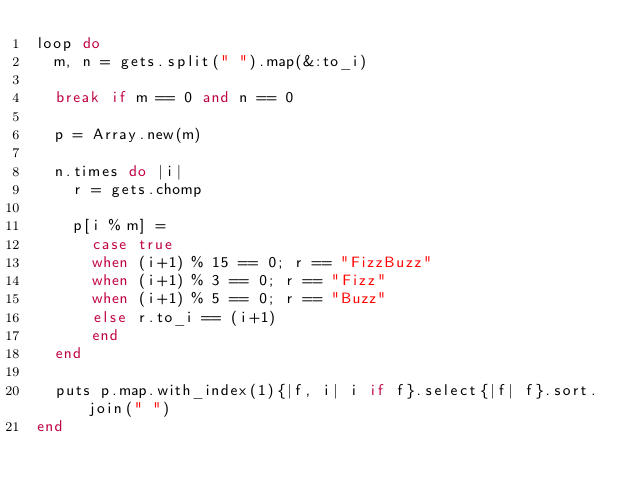<code> <loc_0><loc_0><loc_500><loc_500><_Ruby_>loop do
  m, n = gets.split(" ").map(&:to_i)

  break if m == 0 and n == 0

  p = Array.new(m)

  n.times do |i|
    r = gets.chomp
    
    p[i % m] = 
      case true
      when (i+1) % 15 == 0; r == "FizzBuzz"
      when (i+1) % 3 == 0; r == "Fizz"
      when (i+1) % 5 == 0; r == "Buzz"
      else r.to_i == (i+1)
      end
  end

  puts p.map.with_index(1){|f, i| i if f}.select{|f| f}.sort.join(" ")
end</code> 